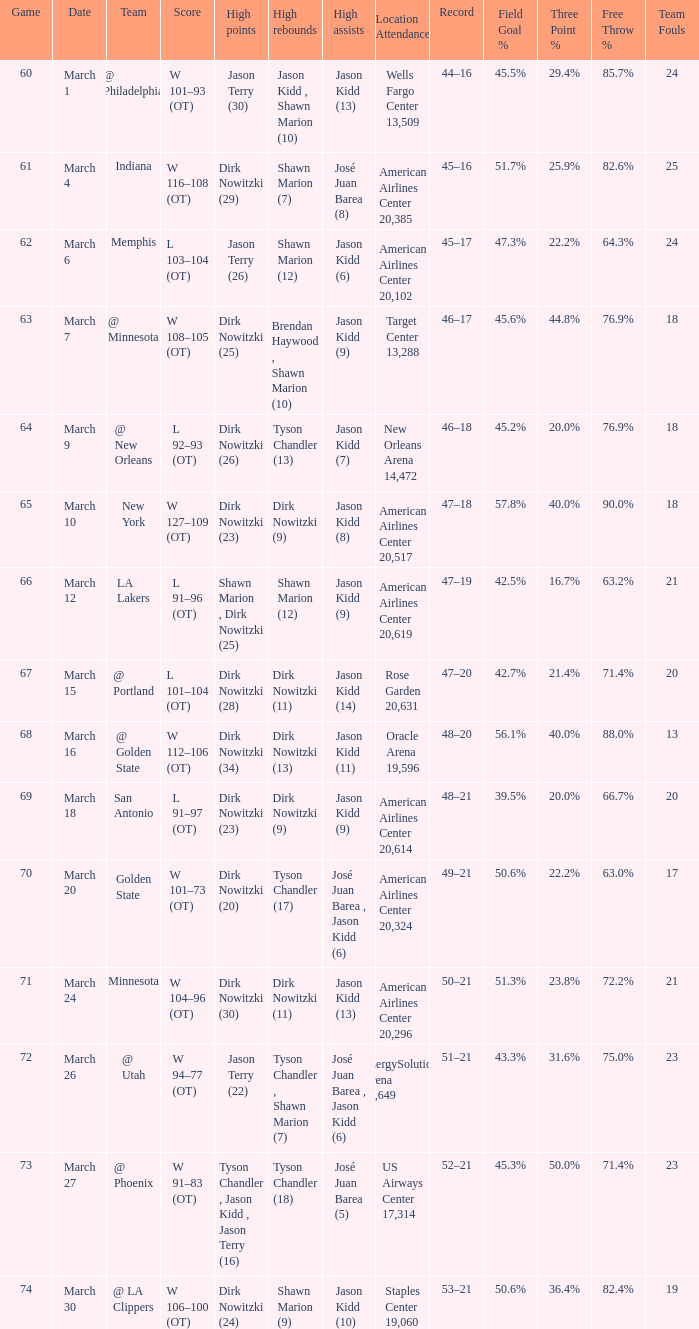Name the high points for march 30 Dirk Nowitzki (24). 